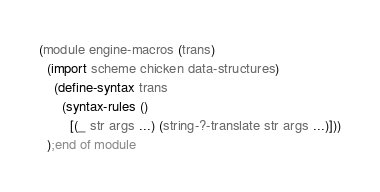<code> <loc_0><loc_0><loc_500><loc_500><_Scheme_>(module engine-macros (trans)
  (import scheme chicken data-structures)
    (define-syntax trans
      (syntax-rules () 
        [(_ str args ...) (string-?-translate str args ...)]))
  );end of module
</code> 